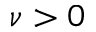Convert formula to latex. <formula><loc_0><loc_0><loc_500><loc_500>\nu > 0</formula> 